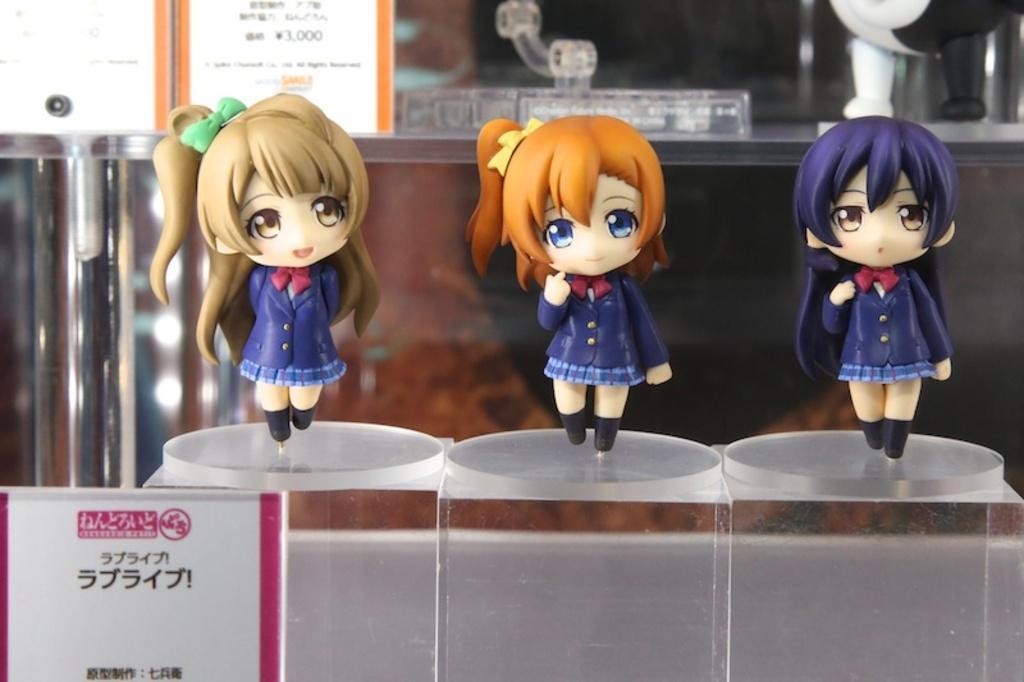In one or two sentences, can you explain what this image depicts? In this image I can see three toys on the glass surface. Back Side I can see few boards and some objects. 